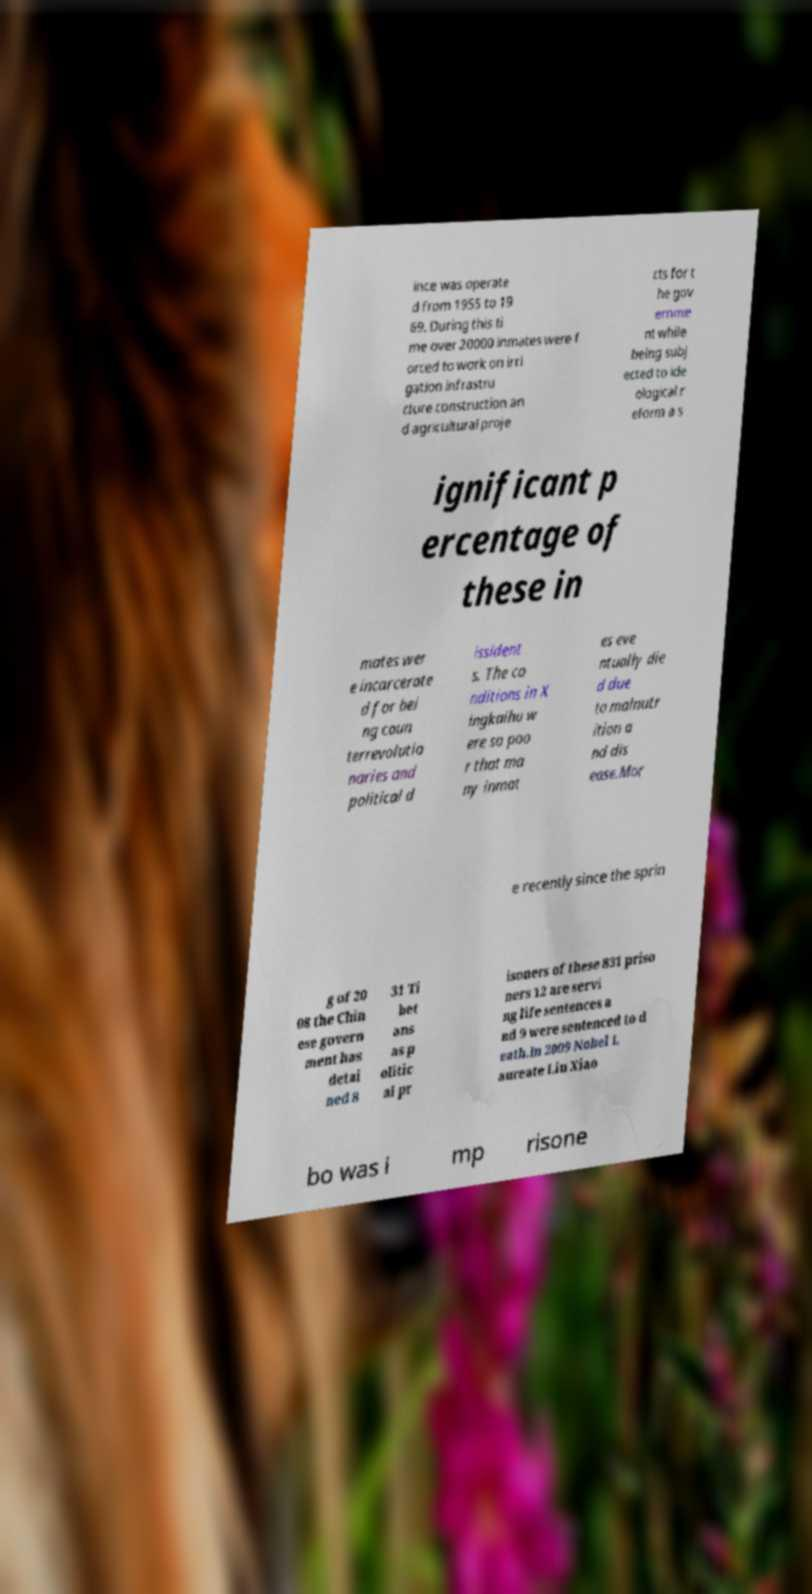Can you accurately transcribe the text from the provided image for me? ince was operate d from 1955 to 19 69. During this ti me over 20000 inmates were f orced to work on irri gation infrastru cture construction an d agricultural proje cts for t he gov ernme nt while being subj ected to ide ological r eform a s ignificant p ercentage of these in mates wer e incarcerate d for bei ng coun terrevolutio naries and political d issident s. The co nditions in X ingkaihu w ere so poo r that ma ny inmat es eve ntually die d due to malnutr ition a nd dis ease.Mor e recently since the sprin g of 20 08 the Chin ese govern ment has detai ned 8 31 Ti bet ans as p olitic al pr isoners of these 831 priso ners 12 are servi ng life sentences a nd 9 were sentenced to d eath.In 2009 Nobel L aureate Liu Xiao bo was i mp risone 